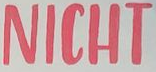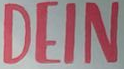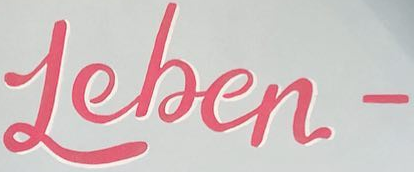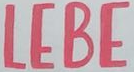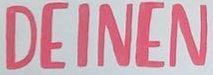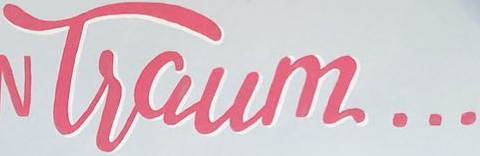What words can you see in these images in sequence, separated by a semicolon? NICHT; DEIN; Leben-; LEBE; DEINEN; Tsaum... 